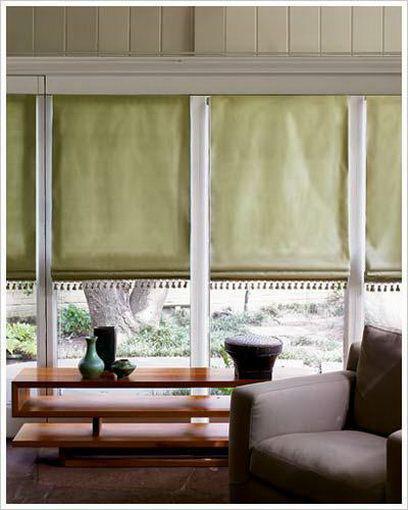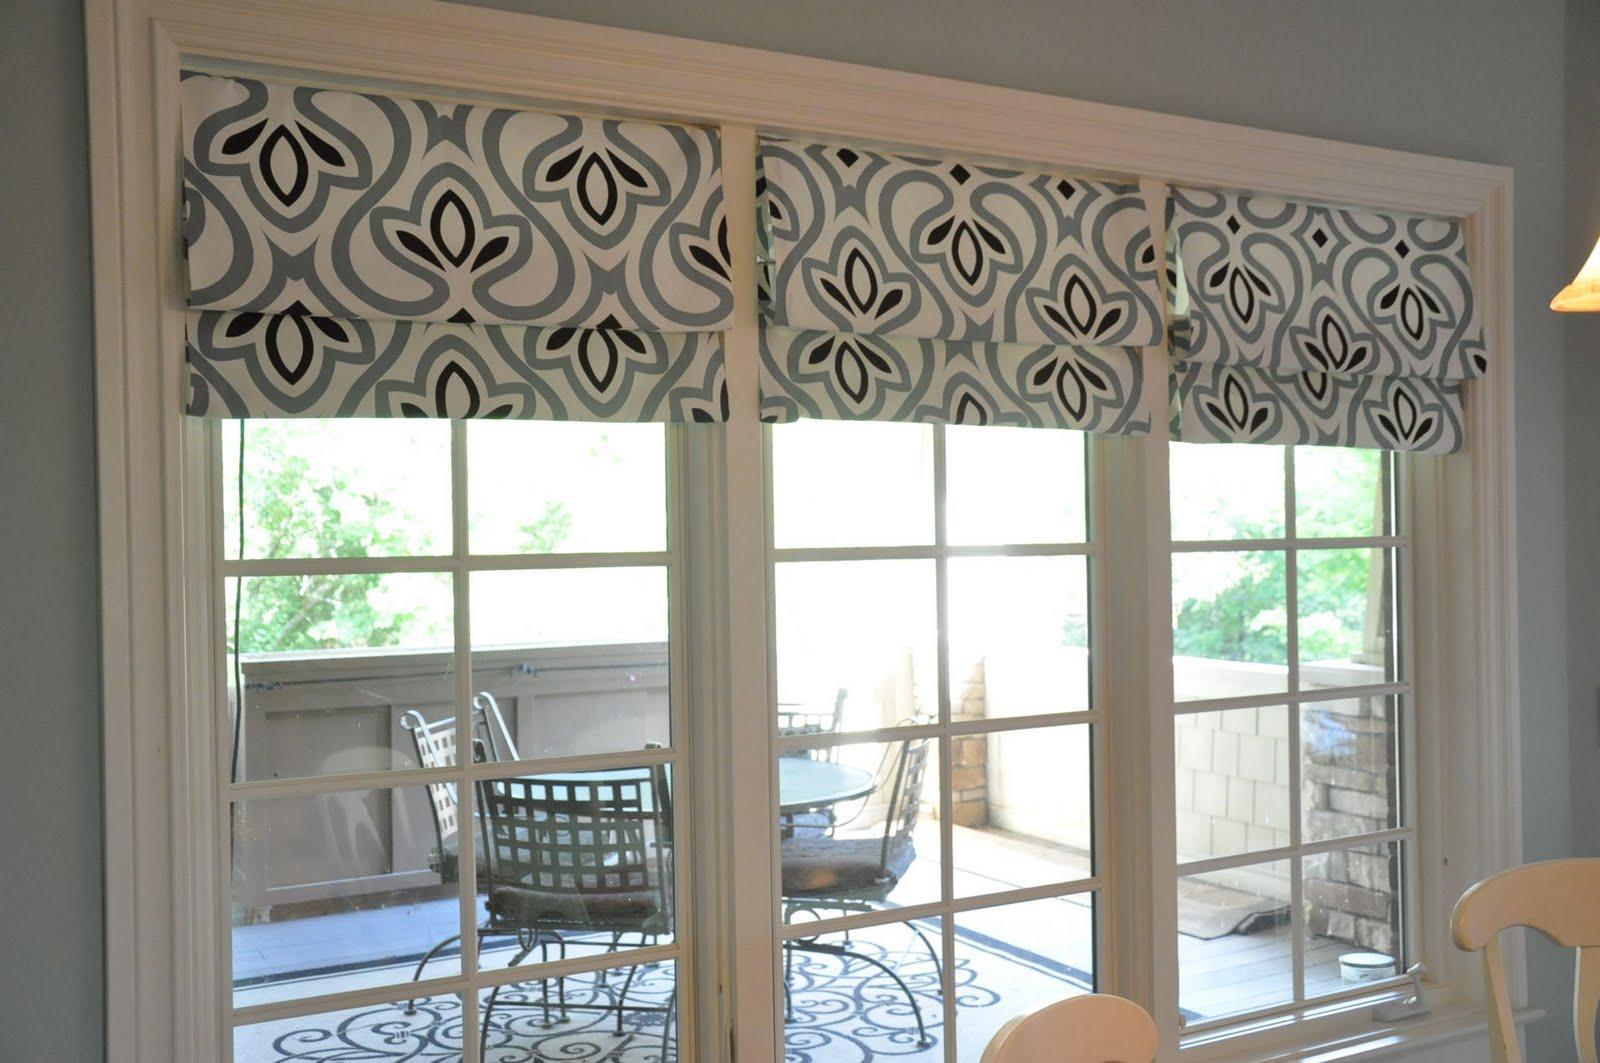The first image is the image on the left, the second image is the image on the right. Considering the images on both sides, is "The right image features a room with at least three windows with rolled up shades printed with bold geometric patterns." valid? Answer yes or no. Yes. The first image is the image on the left, the second image is the image on the right. Examine the images to the left and right. Is the description "In at least one image there is a total of four beige blinds behind a sofa." accurate? Answer yes or no. No. 